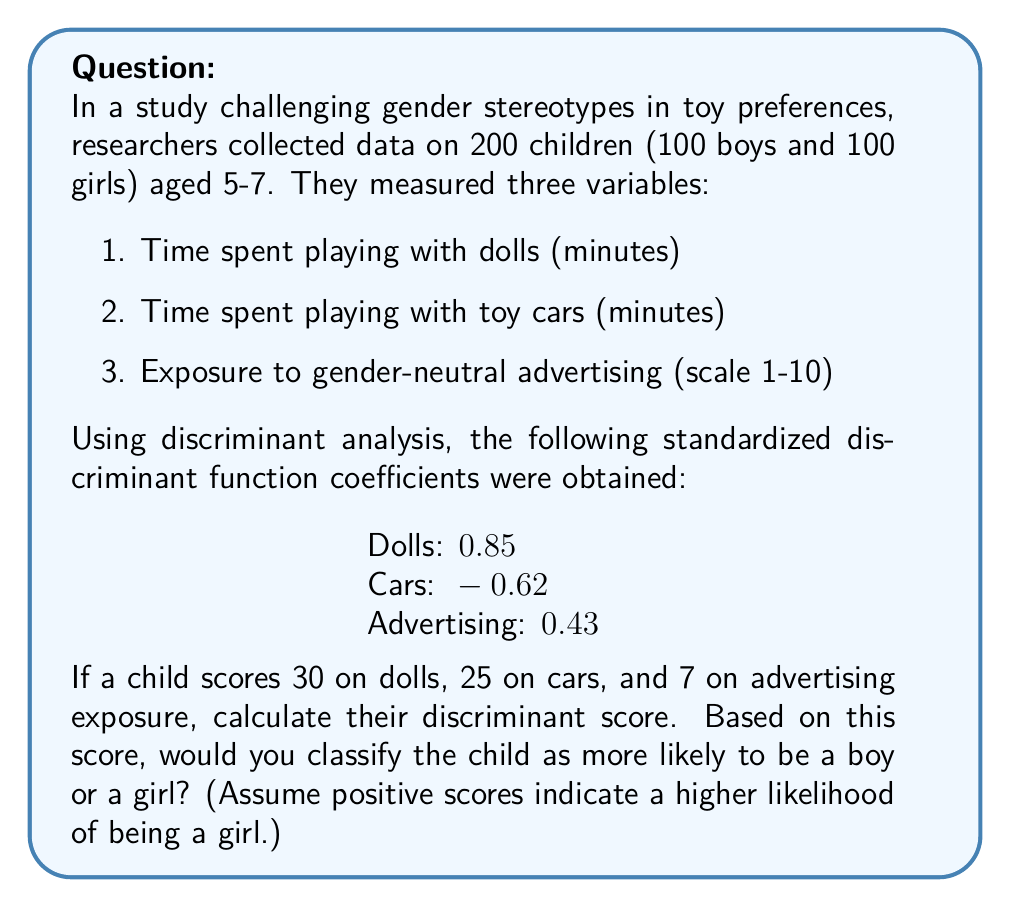Give your solution to this math problem. To solve this problem, we'll follow these steps:

1) The discriminant function is a linear combination of the standardized variables, weighted by their coefficients. The general form is:

   $$D = a_1X_1 + a_2X_2 + a_3X_3 + ... + a_nX_n$$

   Where $D$ is the discriminant score, $a_i$ are the coefficients, and $X_i$ are the standardized variable values.

2) We have the coefficients, but we need to standardize our raw scores. However, since we're not given the mean and standard deviation for each variable, we'll assume the coefficients can be applied directly to the raw scores for this example.

3) Let's plug in our values:
   
   $$D = (0.85 \times 30) + (-0.62 \times 25) + (0.43 \times 7)$$

4) Calculate each term:
   
   $$D = 25.5 + (-15.5) + 3.01$$

5) Sum the terms:
   
   $$D = 13.01$$

6) Interpret the result:
   The positive score (13.01) indicates a higher likelihood of being classified as a girl, based on the assumption that positive scores are associated with girls in this analysis.
Answer: 13.01; likely classified as a girl 